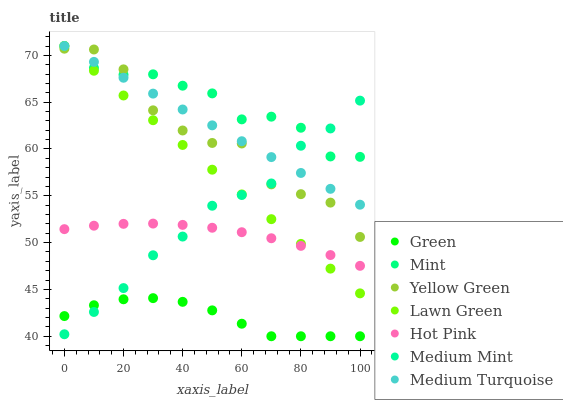Does Green have the minimum area under the curve?
Answer yes or no. Yes. Does Mint have the maximum area under the curve?
Answer yes or no. Yes. Does Lawn Green have the minimum area under the curve?
Answer yes or no. No. Does Lawn Green have the maximum area under the curve?
Answer yes or no. No. Is Medium Turquoise the smoothest?
Answer yes or no. Yes. Is Yellow Green the roughest?
Answer yes or no. Yes. Is Lawn Green the smoothest?
Answer yes or no. No. Is Lawn Green the roughest?
Answer yes or no. No. Does Green have the lowest value?
Answer yes or no. Yes. Does Lawn Green have the lowest value?
Answer yes or no. No. Does Mint have the highest value?
Answer yes or no. Yes. Does Yellow Green have the highest value?
Answer yes or no. No. Is Green less than Lawn Green?
Answer yes or no. Yes. Is Yellow Green greater than Green?
Answer yes or no. Yes. Does Medium Mint intersect Mint?
Answer yes or no. Yes. Is Medium Mint less than Mint?
Answer yes or no. No. Is Medium Mint greater than Mint?
Answer yes or no. No. Does Green intersect Lawn Green?
Answer yes or no. No. 